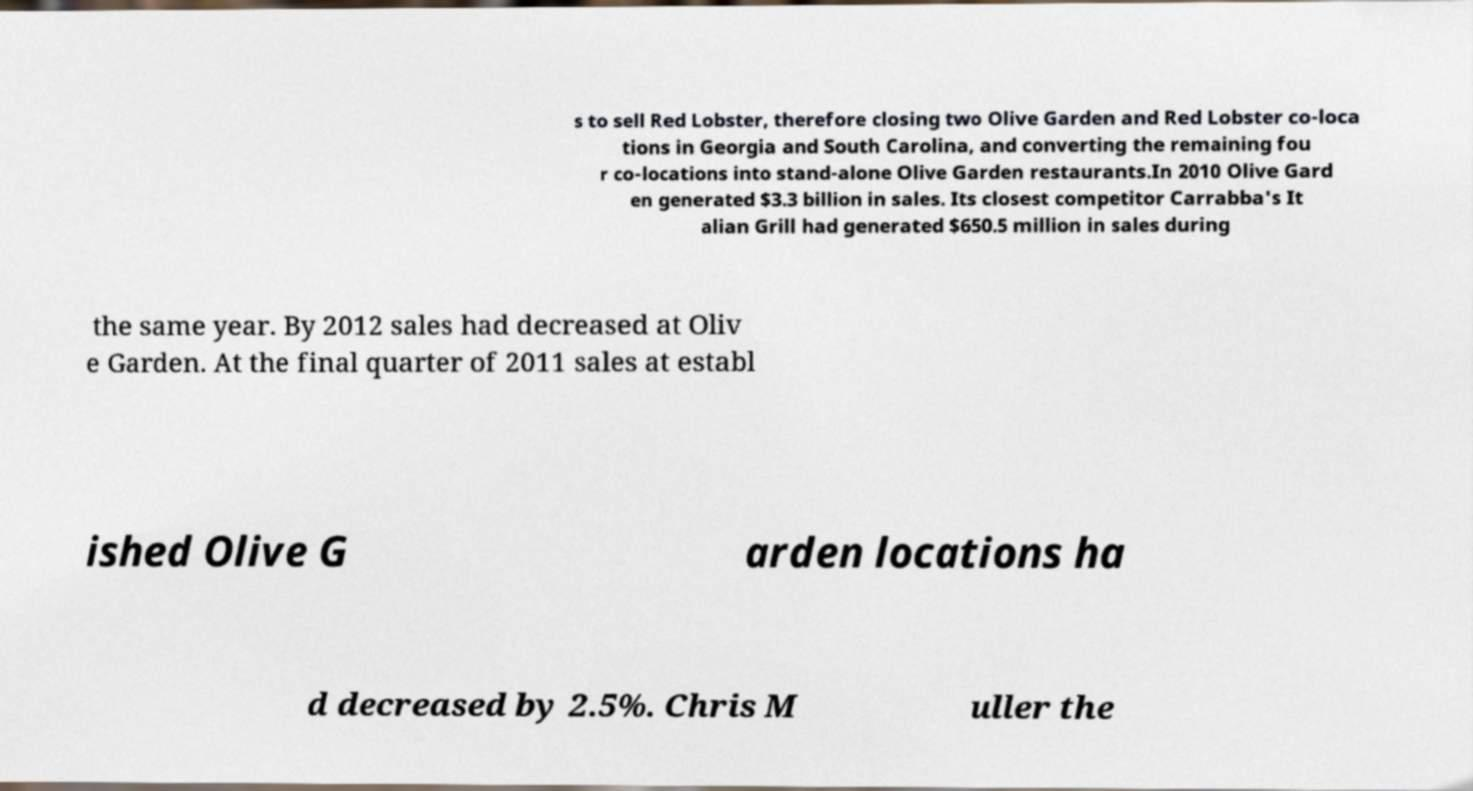There's text embedded in this image that I need extracted. Can you transcribe it verbatim? s to sell Red Lobster, therefore closing two Olive Garden and Red Lobster co-loca tions in Georgia and South Carolina, and converting the remaining fou r co-locations into stand-alone Olive Garden restaurants.In 2010 Olive Gard en generated $3.3 billion in sales. Its closest competitor Carrabba's It alian Grill had generated $650.5 million in sales during the same year. By 2012 sales had decreased at Oliv e Garden. At the final quarter of 2011 sales at establ ished Olive G arden locations ha d decreased by 2.5%. Chris M uller the 